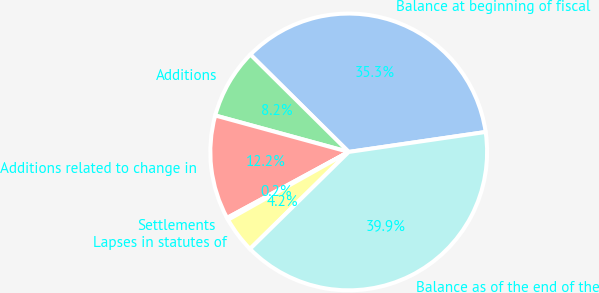Convert chart. <chart><loc_0><loc_0><loc_500><loc_500><pie_chart><fcel>Balance at beginning of fiscal<fcel>Additions<fcel>Additions related to change in<fcel>Settlements<fcel>Lapses in statutes of<fcel>Balance as of the end of the<nl><fcel>35.27%<fcel>8.18%<fcel>12.15%<fcel>0.24%<fcel>4.21%<fcel>39.94%<nl></chart> 